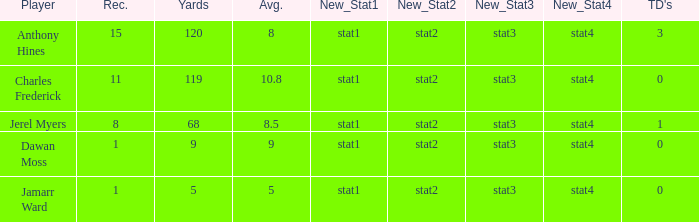What is the total Avg when TDs are 0 and Dawan Moss is a player? 0.0. 